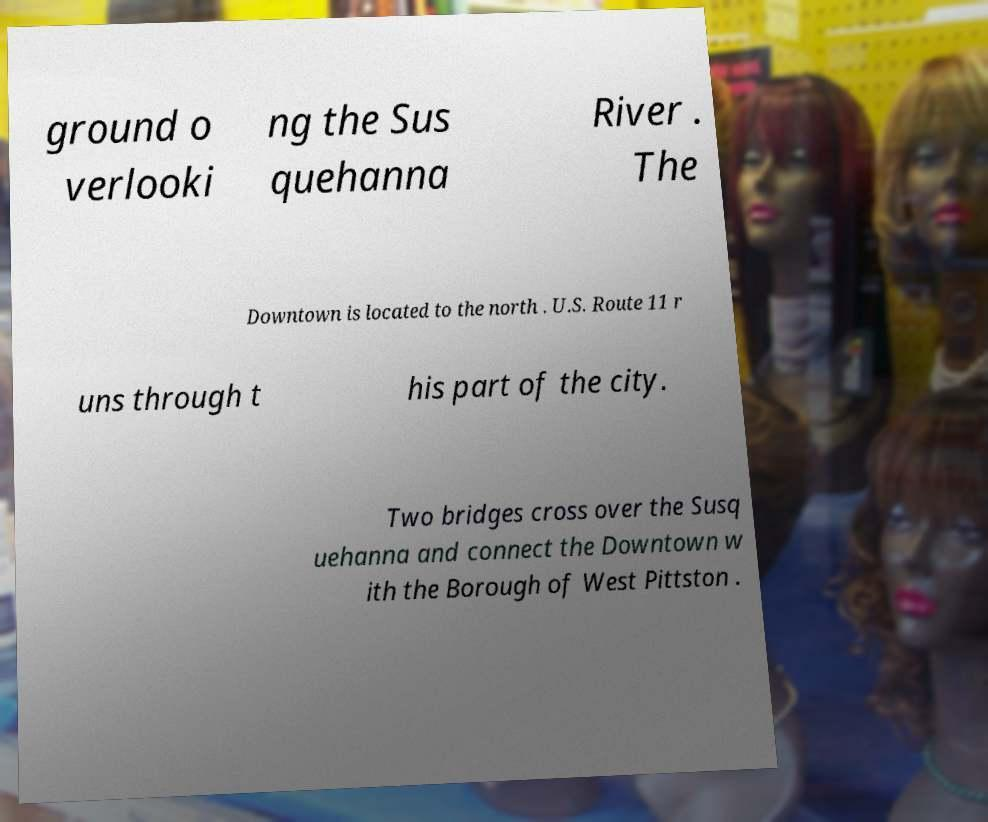Please read and relay the text visible in this image. What does it say? ground o verlooki ng the Sus quehanna River . The Downtown is located to the north . U.S. Route 11 r uns through t his part of the city. Two bridges cross over the Susq uehanna and connect the Downtown w ith the Borough of West Pittston . 